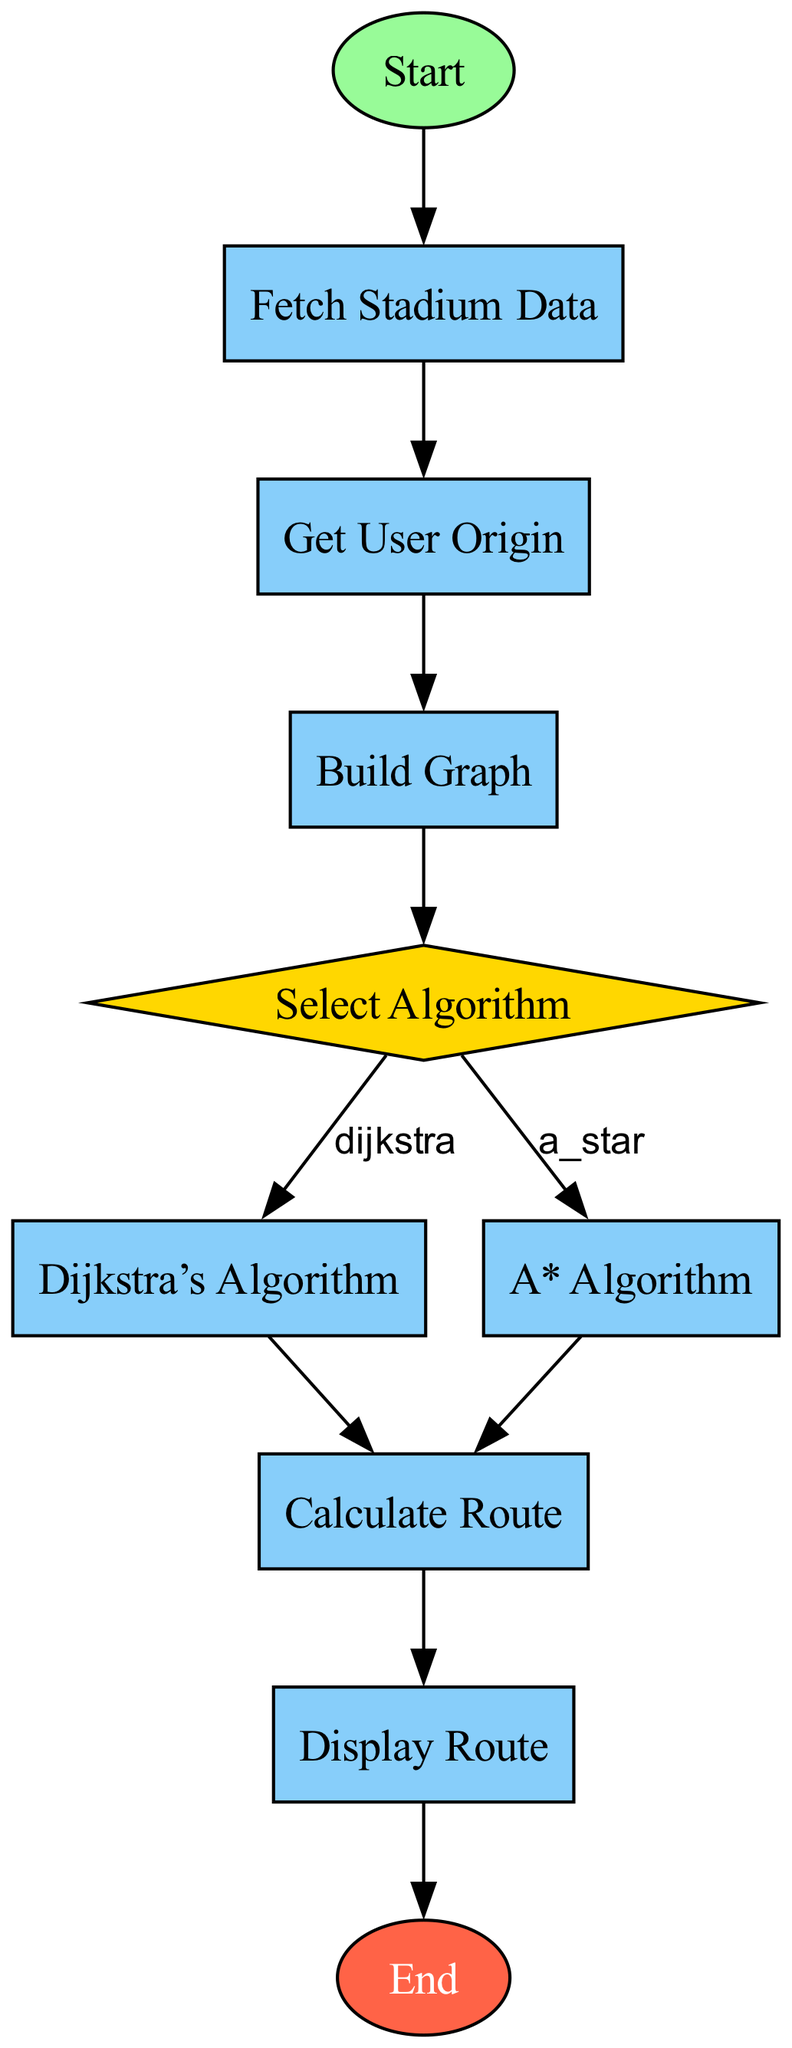What is the first process in the flowchart? The first process in the flowchart is "Fetch Stadium Data," which is the process that initiates after the starting point. This node represents the action of retrieving information about Spanish football stadiums.
Answer: Fetch Stadium Data How many decision nodes are in the diagram? In the diagram, there is one decision node, labeled "Select Algorithm." A decision node typically indicates a branching point in the flowchart where different paths can be taken based on a certain condition.
Answer: 1 What is the last process before the end node? The last process before reaching the end node is "Display Route." This indicates that after calculating the cheapest route between the stadiums, the results will be shown before finalizing the flow.
Answer: Display Route If Dijkstra's Algorithm is selected, what is the next process? If Dijkstra's Algorithm is chosen at the "Select Algorithm" decision node, the flowchart will lead to the "Dijkstra’s Algorithm" process. This is the next step to run the algorithm specifically for calculating the route.
Answer: Dijkstra’s Algorithm What happens after fetching stadium data? After fetching stadium data, the next step is to "Get User Origin." This step collects the starting location of the travel blogger, which is essential for determining the travel route.
Answer: Get User Origin In which node does the selection of algorithms occur? The selection of algorithms occurs in the "Select Algorithm" node. Here, the user chooses whether to utilize Dijkstra's or A* Algorithm for calculating the route, leading to a bifurcation in the flow.
Answer: Select Algorithm What is indicated by the node labeled "Calculate Route"? The "Calculate Route" node shows that, regardless of which algorithm was selected earlier (either Dijkstra or A*), this is the point where the chosen algorithm executes to determine the best travel route between the designated stadiums.
Answer: Calculate Route 